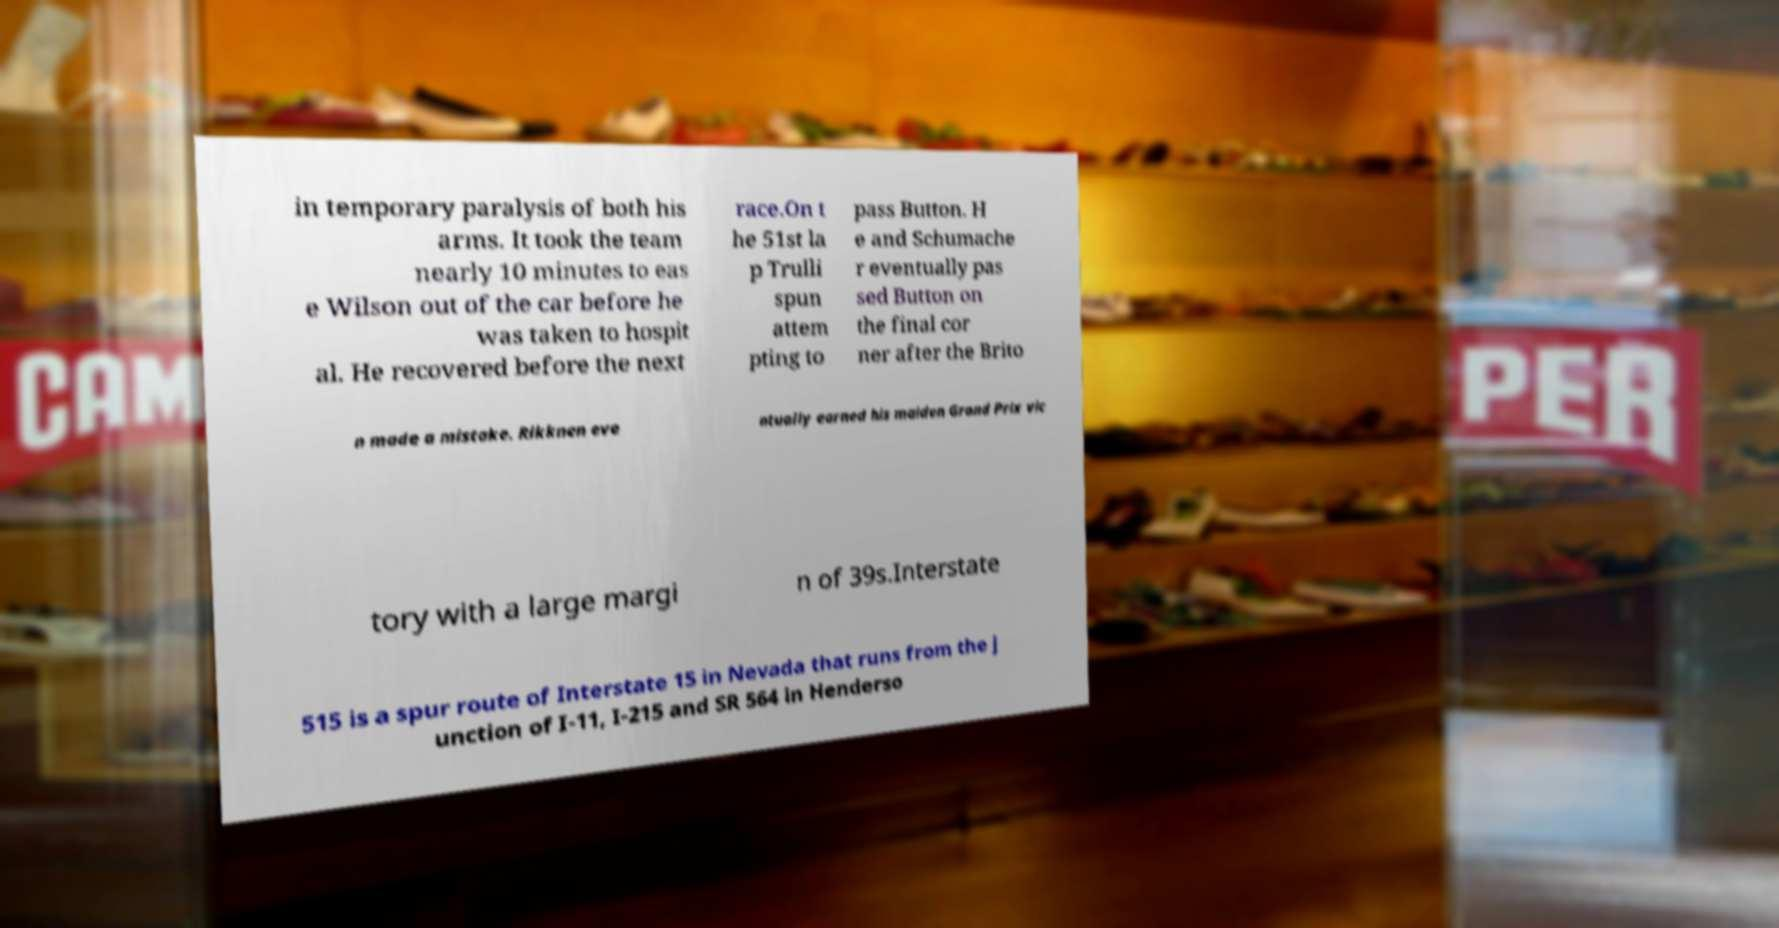I need the written content from this picture converted into text. Can you do that? in temporary paralysis of both his arms. It took the team nearly 10 minutes to eas e Wilson out of the car before he was taken to hospit al. He recovered before the next race.On t he 51st la p Trulli spun attem pting to pass Button. H e and Schumache r eventually pas sed Button on the final cor ner after the Brito n made a mistake. Rikknen eve ntually earned his maiden Grand Prix vic tory with a large margi n of 39s.Interstate 515 is a spur route of Interstate 15 in Nevada that runs from the j unction of I-11, I-215 and SR 564 in Henderso 